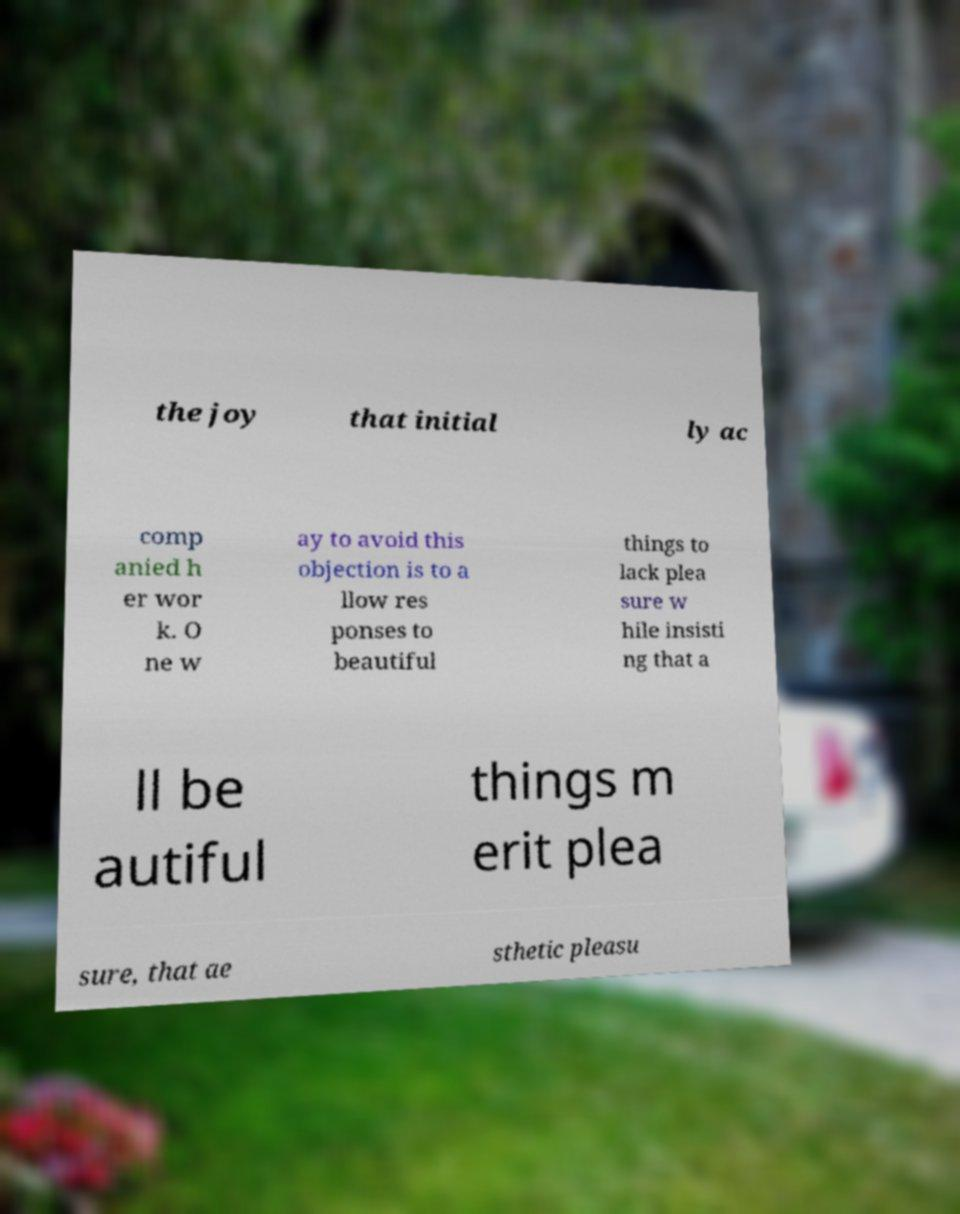I need the written content from this picture converted into text. Can you do that? the joy that initial ly ac comp anied h er wor k. O ne w ay to avoid this objection is to a llow res ponses to beautiful things to lack plea sure w hile insisti ng that a ll be autiful things m erit plea sure, that ae sthetic pleasu 